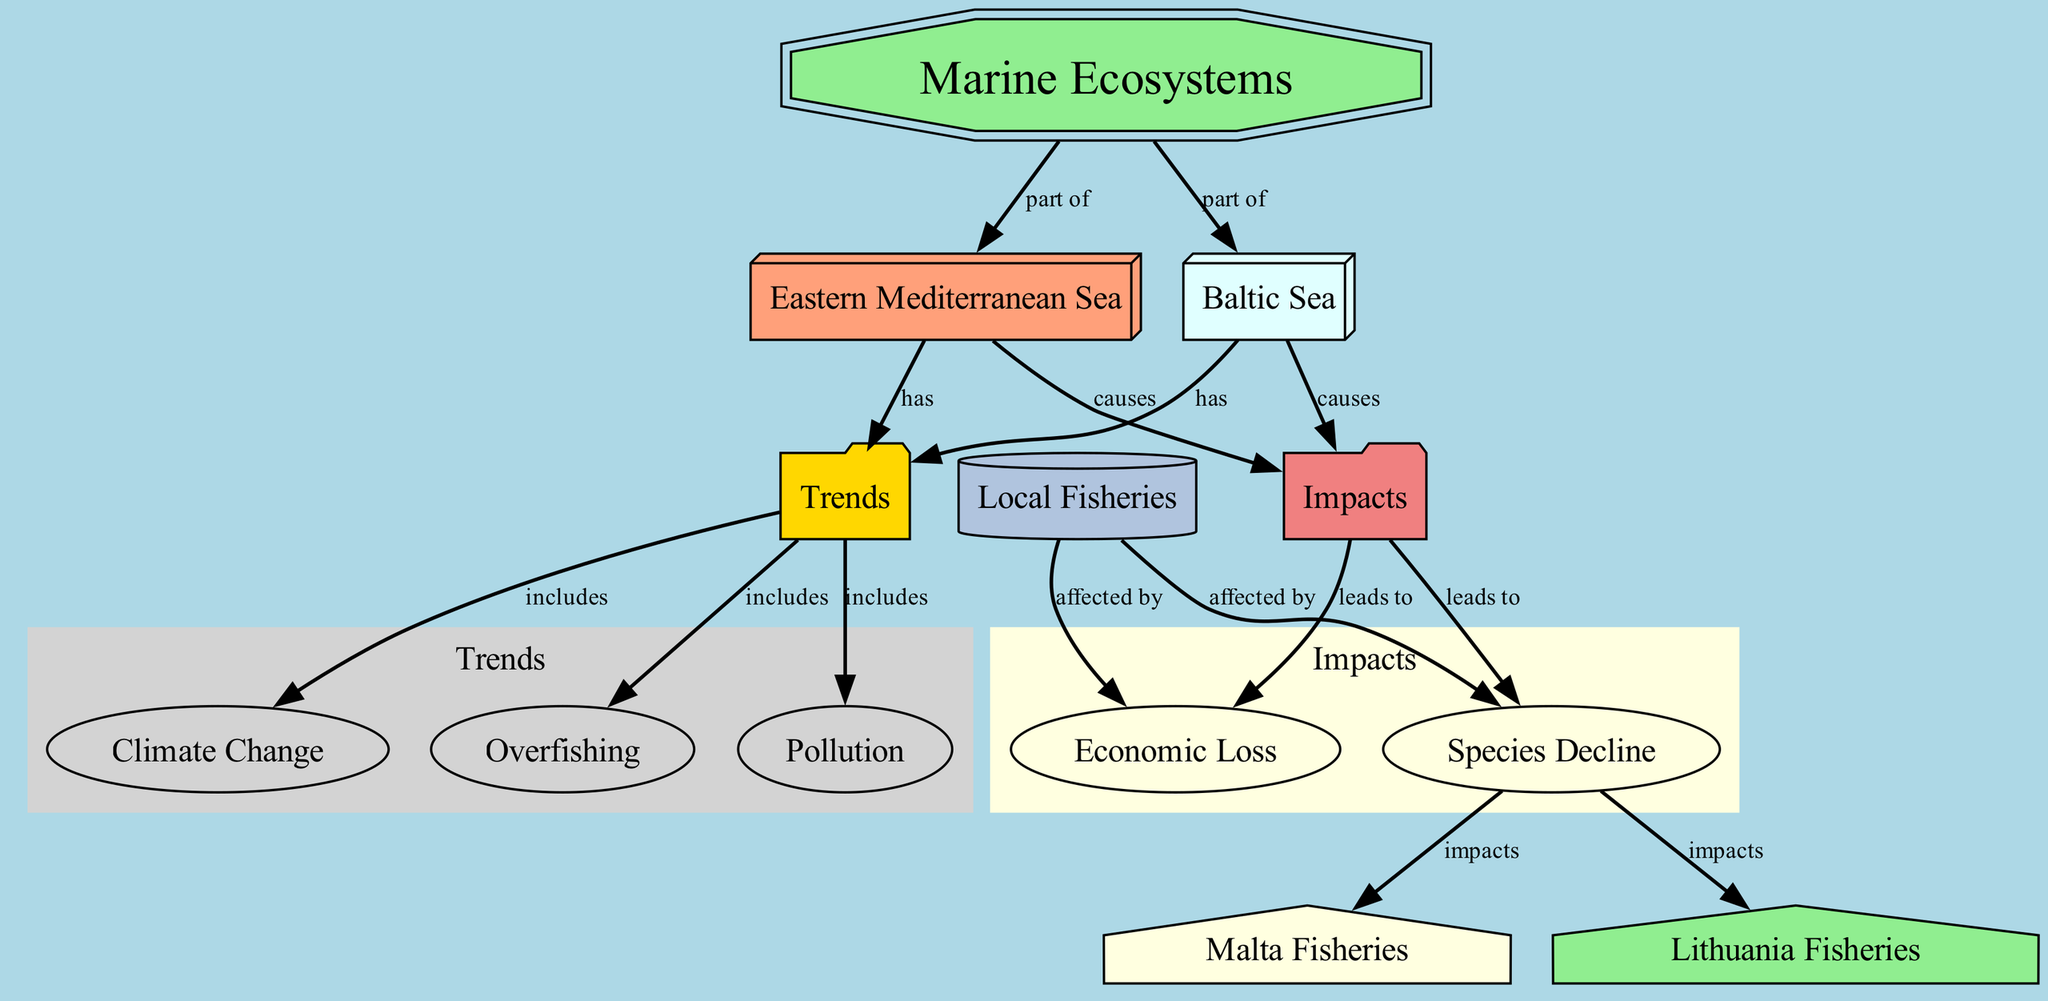What's the total number of nodes in the diagram? By counting all the nodes listed in the diagram’s data section, we find 12 distinct nodes: marine ecosystems, eastern Mediterranean Sea, Baltic Sea, trends, climate change, overfishing, pollution, impacts, fisheries, species decline, economic loss, Malta fisheries, and Lithuania fisheries.
Answer: 12 What relationship does the Eastern Mediterranean Sea have with trends? According to the edges in the diagram, the Eastern Mediterranean Sea "has" trends indicated by an arrow connecting the two nodes.
Answer: has Which two factors are included in the trends of both seas? Both the Eastern Mediterranean Sea and the Baltic Sea report trends that include climate change and overfishing. By analyzing the edges, we observe these connections from the trends node.
Answer: climate change, overfishing What is the primary impact of the marine ecosystems on local fisheries? The diagram indicates that local fisheries are affected by species decline and economic loss, both of which are shown as consequences of impacts resulting from the Eastern Mediterranean Sea and Baltic Sea.
Answer: species decline, economic loss How many distinct impacts result from the trends observed in the marine ecosystems? The diagram shows that there are two distinct impacts — species decline and economic loss. These are linked through the impacts node, which connects to both of these outcomes.
Answer: 2 How do trends in the Eastern Mediterranean Sea affect fisheries specifically in Malta? The impact of species decline directly affects Malta fisheries, as indicated by the arrows that connect species decline to Malta fisheries, showing the consequence of the overall trends in the ecosystem.
Answer: impacts Which sea is more associated with pollution based on the diagram's layout? Both seas have the same trends, including pollution, but the diagram illustrates impacts stemming from both the Eastern Mediterranean Sea and Baltic Sea. There is no specific indication that one sea is more associated with pollution than the other.
Answer: both seas are equally associated What does the node labeled "impacts" lead to? The impacts node leads to two other nodes, illustrating the consequences of these impacts: species decline and economic loss, which are directly connected to the impacts node.
Answer: species decline, economic loss 